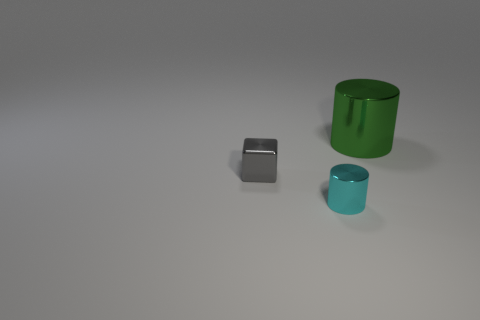Add 2 shiny cylinders. How many objects exist? 5 Subtract all cubes. How many objects are left? 2 Subtract all rubber cubes. Subtract all metal cylinders. How many objects are left? 1 Add 3 tiny gray shiny blocks. How many tiny gray shiny blocks are left? 4 Add 2 small gray metal cubes. How many small gray metal cubes exist? 3 Subtract 0 red cubes. How many objects are left? 3 